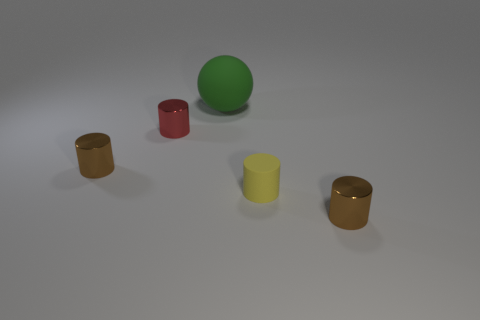Subtract all yellow cylinders. Subtract all brown spheres. How many cylinders are left? 3 Add 2 red metal cylinders. How many objects exist? 7 Subtract all balls. How many objects are left? 4 Add 3 yellow cylinders. How many yellow cylinders exist? 4 Subtract 0 cyan blocks. How many objects are left? 5 Subtract all big green objects. Subtract all big green cylinders. How many objects are left? 4 Add 1 small matte cylinders. How many small matte cylinders are left? 2 